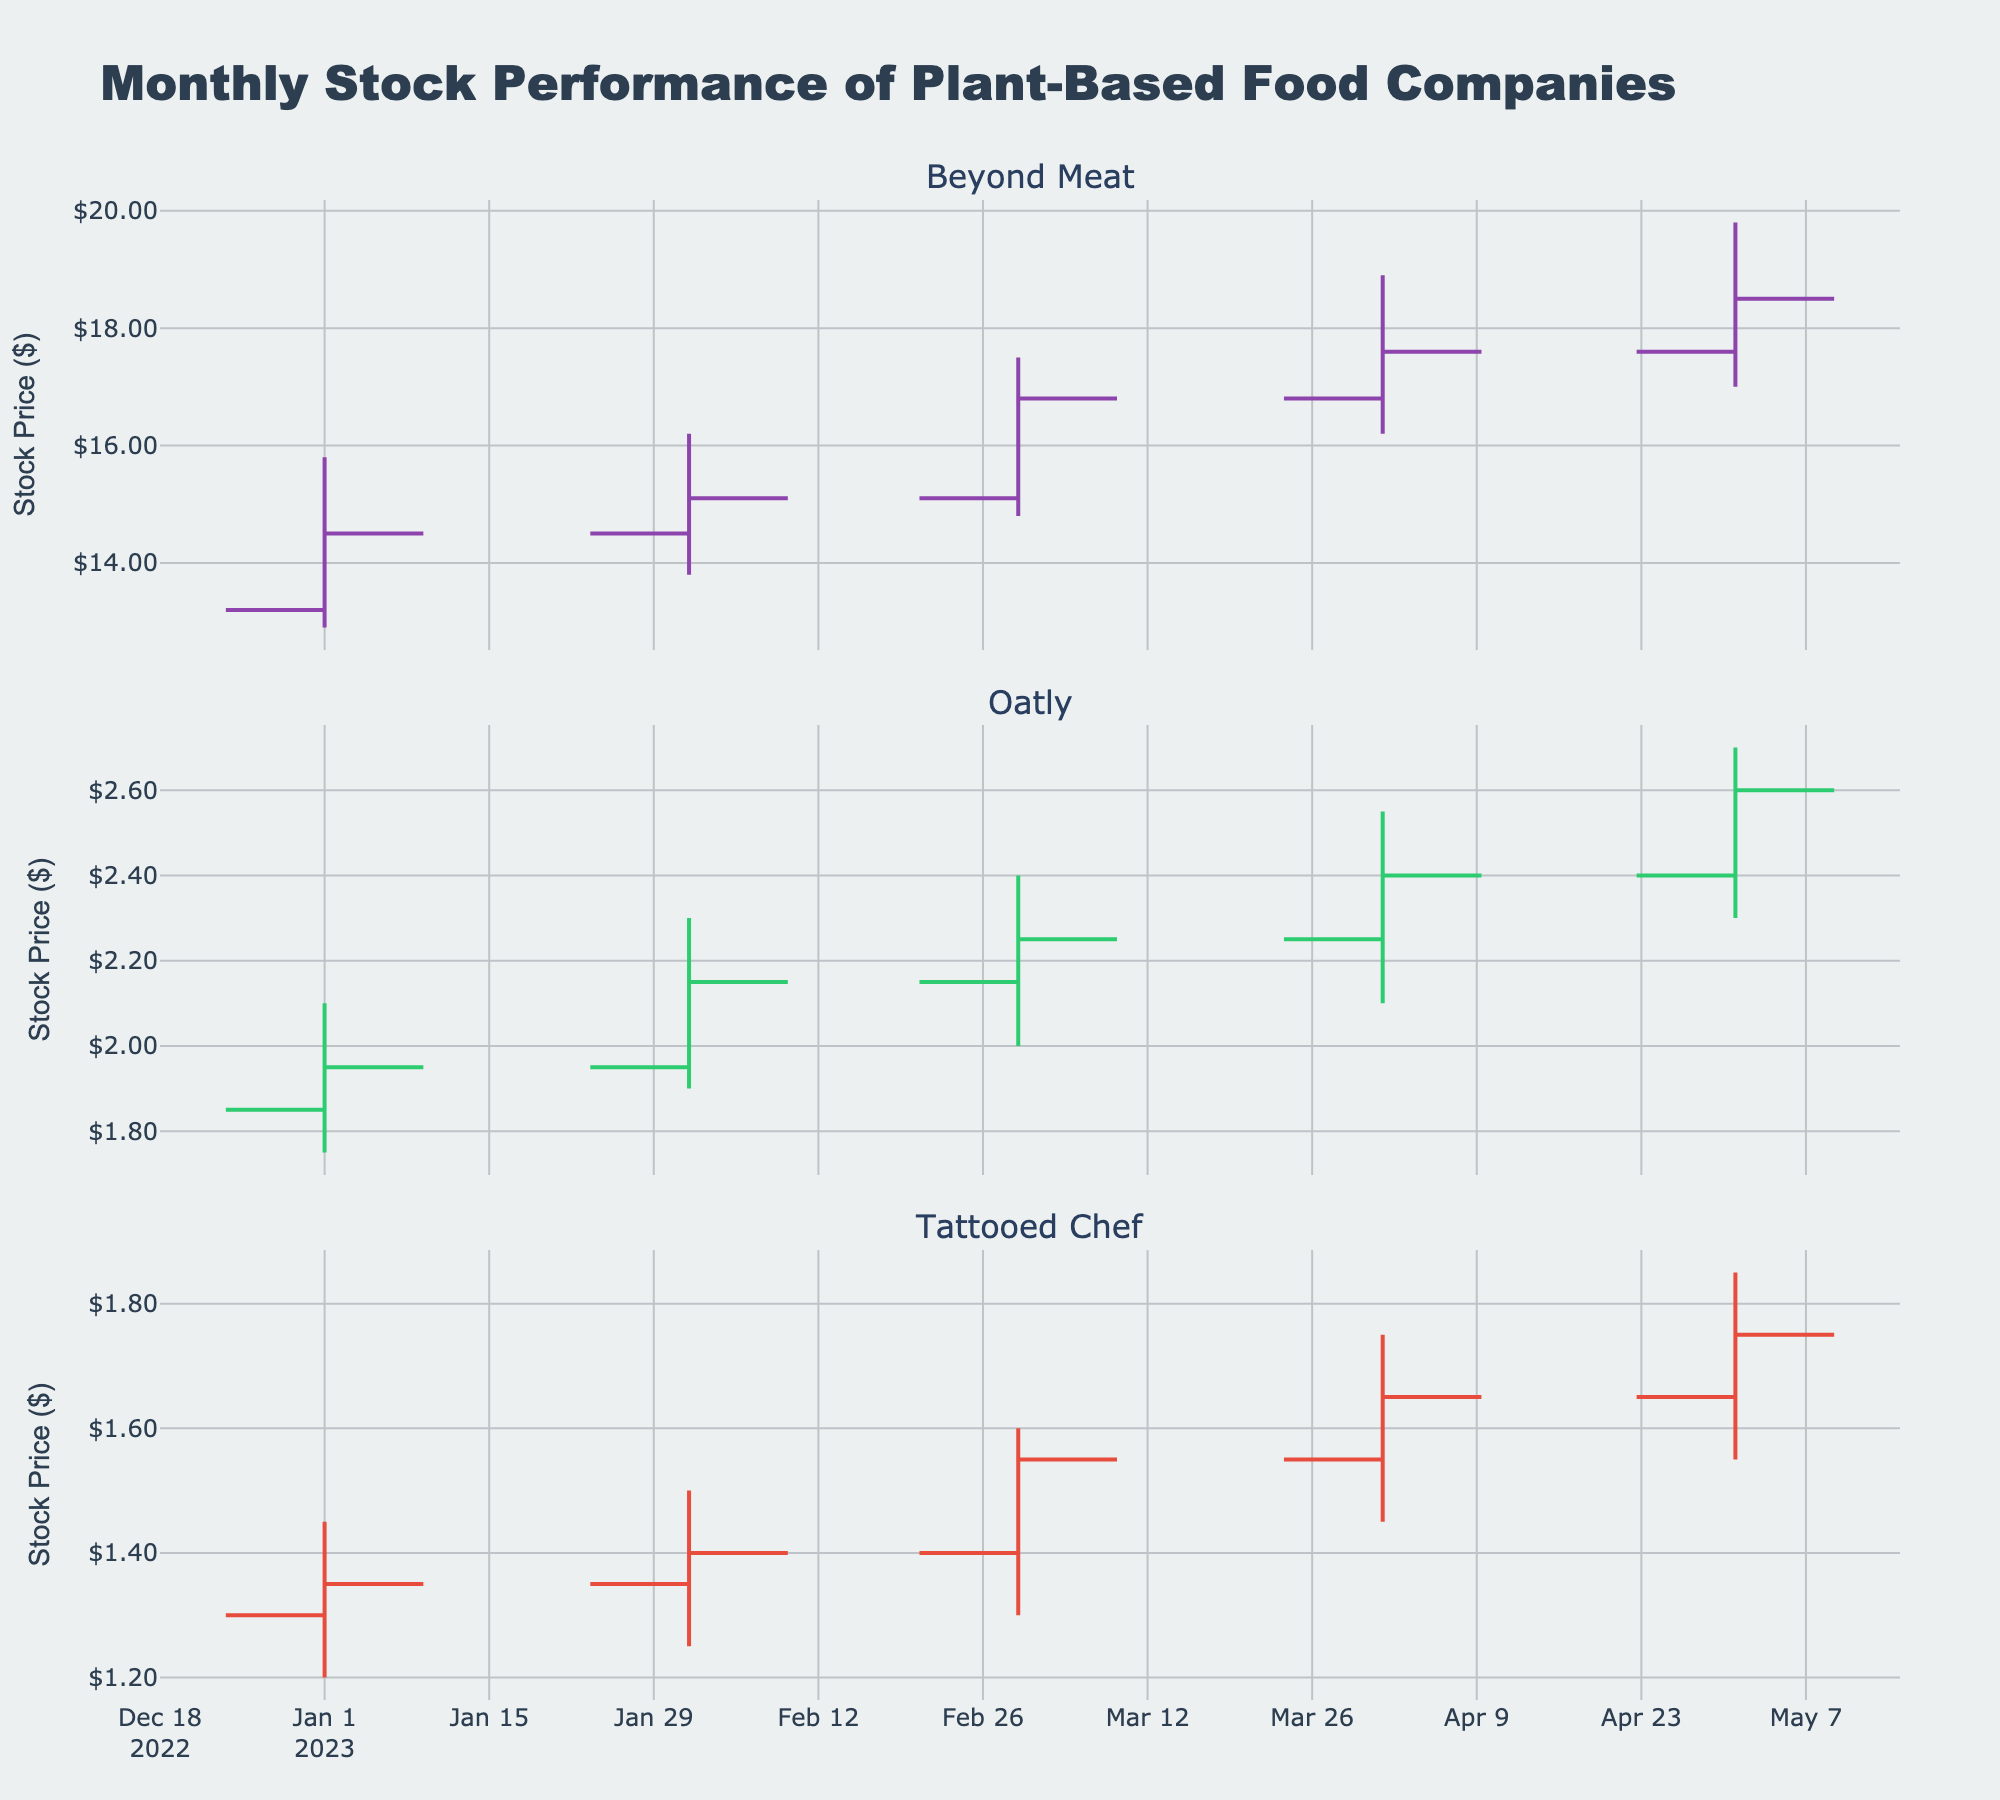what is the title of the figure? The title is mentioned at the top of the figure. It reads "Monthly Stock Performance of Plant-Based Food Companies".
Answer: Monthly Stock Performance of Plant-Based Food Companies What is the color used for the increasing line of Beyond Meat's stock? The increasing line color for Beyond Meat’s stock can be seen in the subplot titled "Beyond Meat". It is a shade of purple.
Answer: purple What months did Beyond Meat's stock have an increasing closing value? By observing the OHLC charts for Beyond Meat, the closing values increase from January to February, February to March, and March to April. However, from April to May, the closing value continued to increase.
Answer: January to February, February to March, March to April, April to May What is the lowest price Tattooed Chef stock reached in the time frame considered? This can be seen by looking at the lowest values on the Tattooed Chef subplot. The lowest price reached by Tattooed Chef stock is 1.20 in January 2023.
Answer: 1.20 Which company had the highest closing stock price in March 2023? By observing the closing values in March 2023 for each company, Beyond Meat had the highest closing price at 16.80.
Answer: Beyond Meat Compare the opening prices of Oatly and Tattooed Chef in April 2023. Which is higher and by how much? The opening price for Oatly in April 2023 is 2.25, and for Tattooed Chef, it is 1.55. 2.25 - 1.55 = 0.70, so Oatly's opening price is higher by 0.70.
Answer: Oatly, higher by 0.70 Which month did Oatly's stock price have the highest peak value recorded? By looking at the high value of Oatly's stock across the range, it reached its peak value of 2.70 in May 2023.
Answer: May 2023 How did the stock price of Beyond Meat change from January 2023 to May 2023? The opening price of Beyond Meat in January 2023 was 13.20 and it closed at 18.50 in May 2023. Therefore, the stock increased by 18.50 - 13.20 = 5.30.
Answer: Increased by 5.30 What was the closing price of Oatly in February 2023? This is directly observable from the Oatly subplot for February 2023. The closing price was 2.15.
Answer: 2.15 